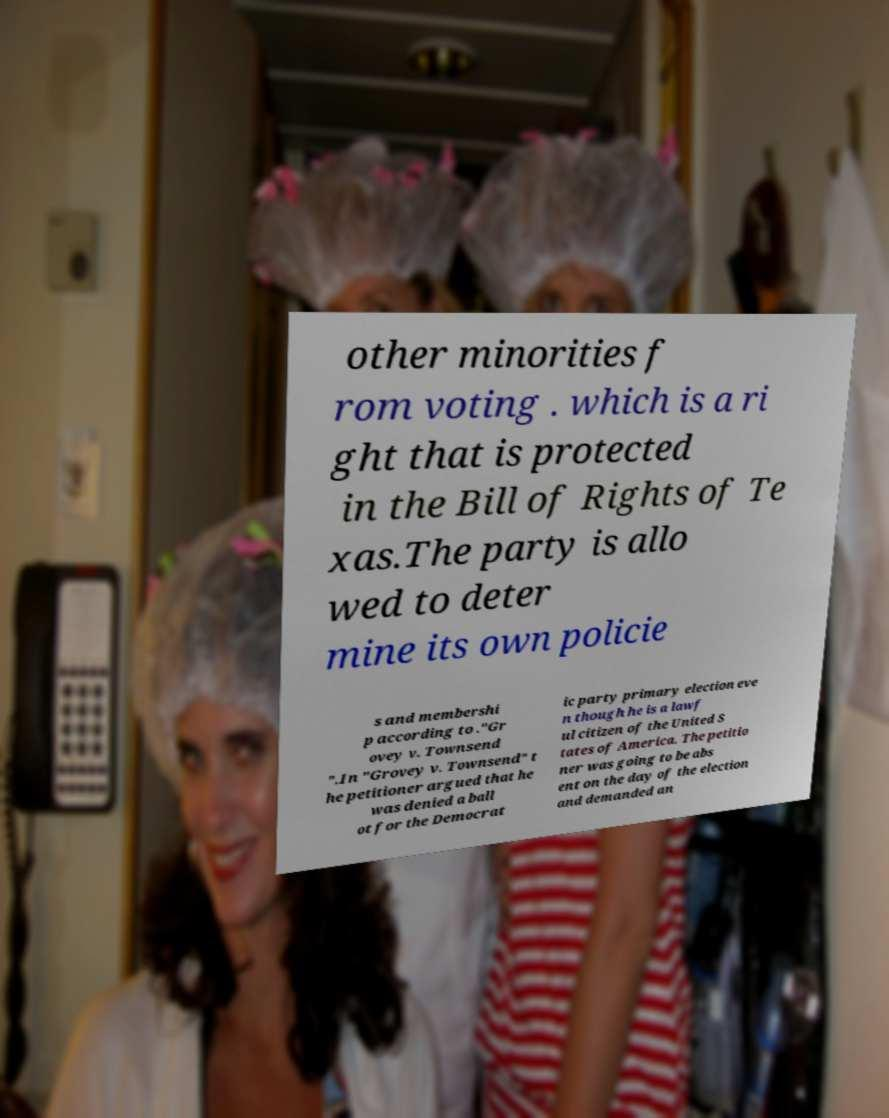There's text embedded in this image that I need extracted. Can you transcribe it verbatim? other minorities f rom voting . which is a ri ght that is protected in the Bill of Rights of Te xas.The party is allo wed to deter mine its own policie s and membershi p according to ."Gr ovey v. Townsend ".In "Grovey v. Townsend" t he petitioner argued that he was denied a ball ot for the Democrat ic party primary election eve n though he is a lawf ul citizen of the United S tates of America. The petitio ner was going to be abs ent on the day of the election and demanded an 